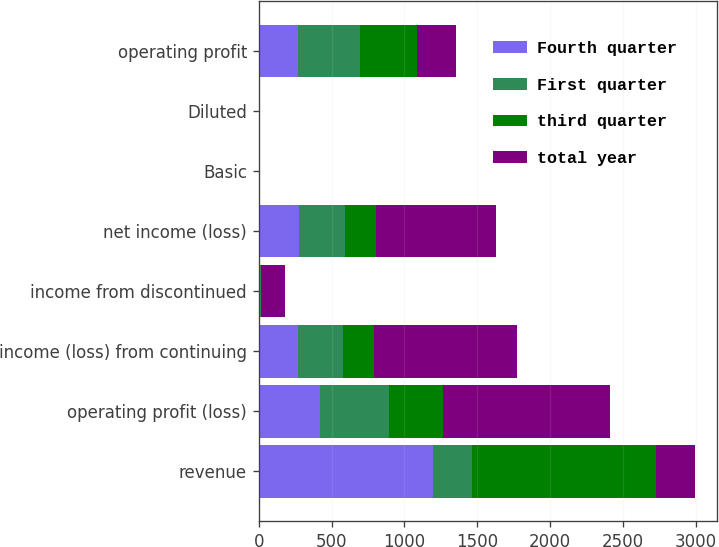Convert chart to OTSL. <chart><loc_0><loc_0><loc_500><loc_500><stacked_bar_chart><ecel><fcel>revenue<fcel>operating profit (loss)<fcel>income (loss) from continuing<fcel>income from discontinued<fcel>net income (loss)<fcel>Basic<fcel>Diluted<fcel>operating profit<nl><fcel>Fourth quarter<fcel>1196<fcel>420<fcel>268<fcel>7<fcel>275<fcel>0.89<fcel>0.87<fcel>269<nl><fcel>First quarter<fcel>268.5<fcel>476<fcel>310<fcel>6<fcel>316<fcel>1.05<fcel>1.04<fcel>423<nl><fcel>third quarter<fcel>1263<fcel>366<fcel>215<fcel>2<fcel>217<fcel>0.69<fcel>0.68<fcel>395<nl><fcel>total year<fcel>268.5<fcel>1148<fcel>984<fcel>163<fcel>821<fcel>3.71<fcel>3.71<fcel>271<nl></chart> 